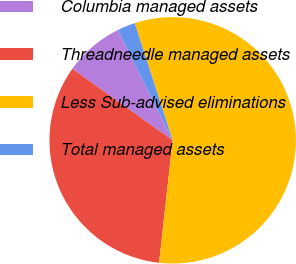<chart> <loc_0><loc_0><loc_500><loc_500><pie_chart><fcel>Columbia managed assets<fcel>Threadneedle managed assets<fcel>Less Sub-advised eliminations<fcel>Total managed assets<nl><fcel>7.8%<fcel>33.1%<fcel>56.74%<fcel>2.36%<nl></chart> 